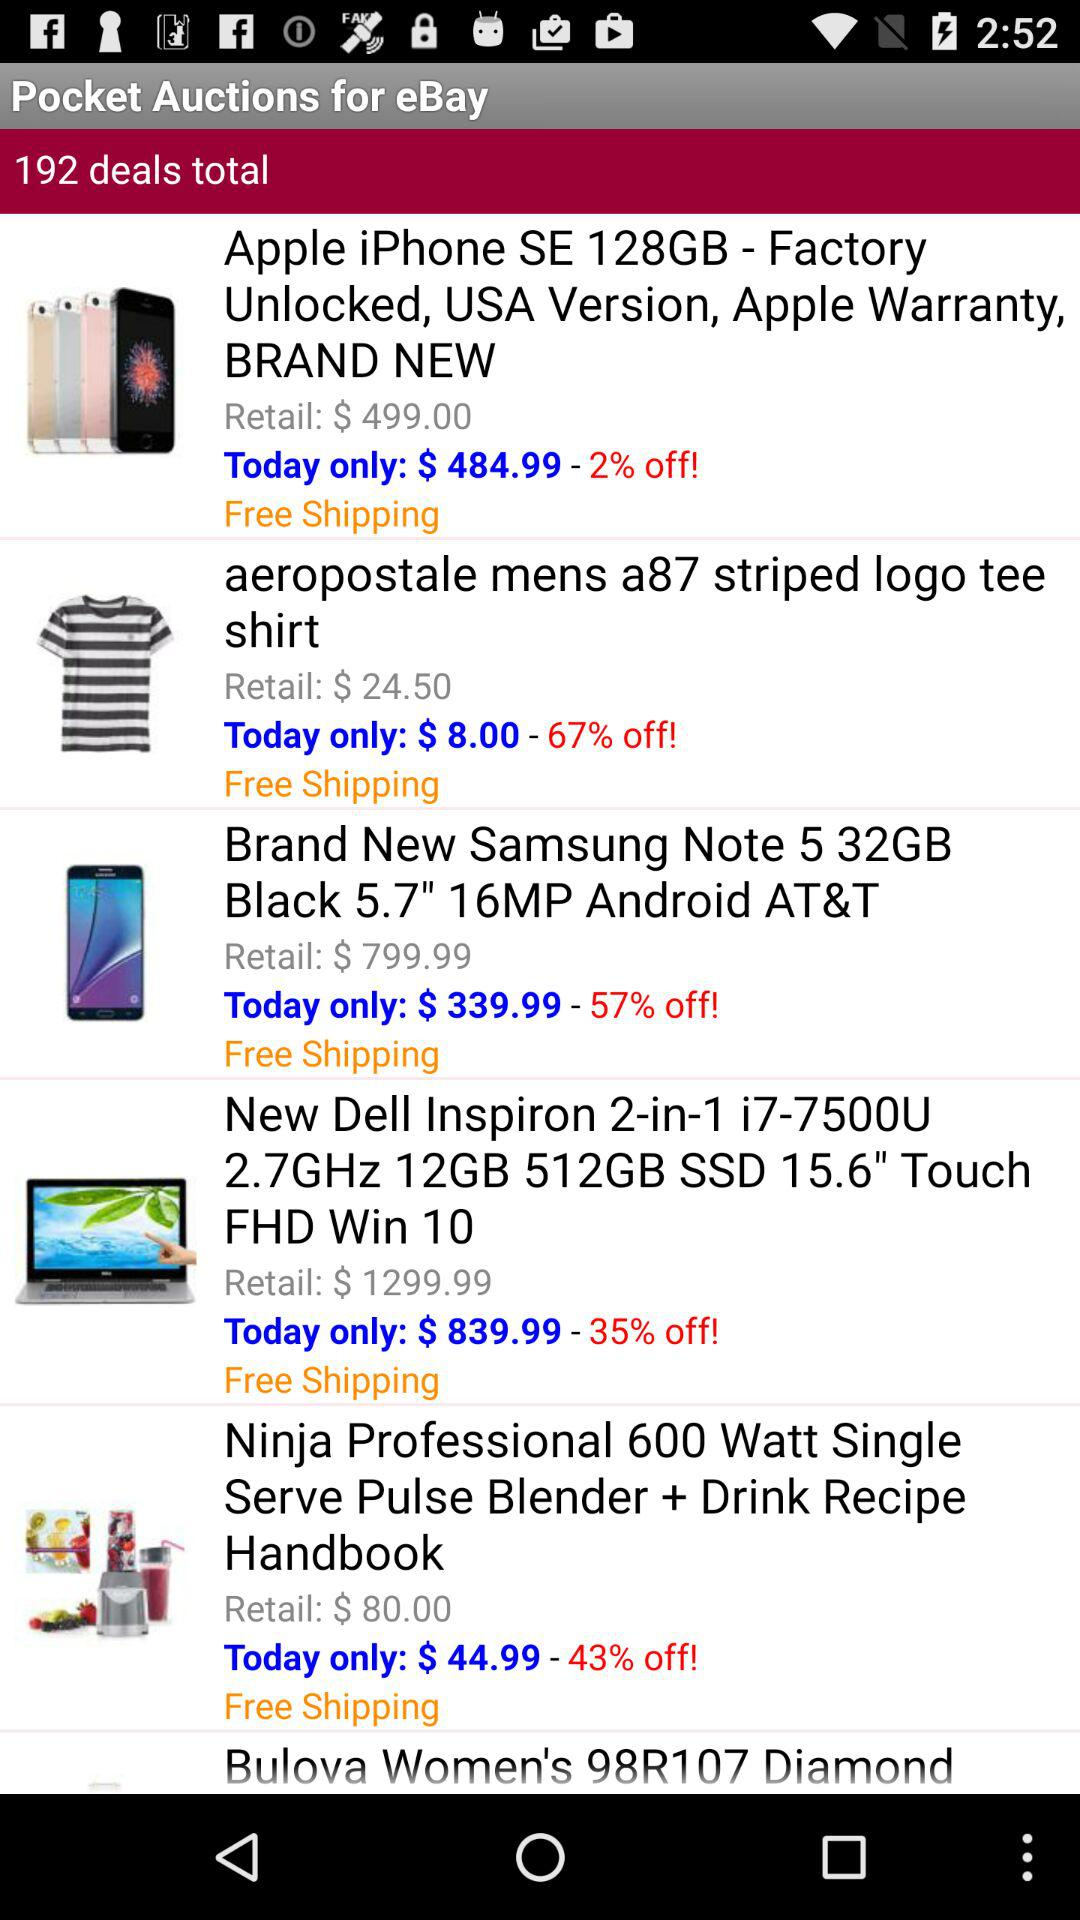What is the retail price of the "Ninja Professional 600 Watt Single Serve Pulse Blender + Drink Recipe Handbook"? The retail price is $80. 